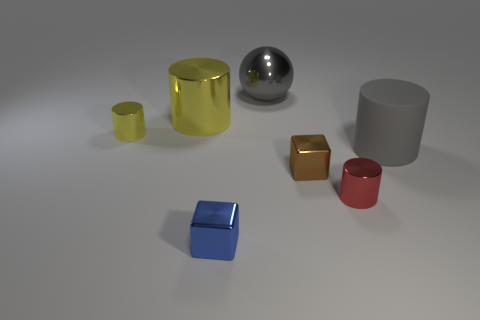Subtract all gray cylinders. How many cylinders are left? 3 Subtract all gray cylinders. How many cylinders are left? 3 Add 3 matte objects. How many objects exist? 10 Subtract all brown cylinders. Subtract all brown balls. How many cylinders are left? 4 Subtract all cylinders. How many objects are left? 3 Subtract all big blue matte spheres. Subtract all big gray matte cylinders. How many objects are left? 6 Add 3 blue objects. How many blue objects are left? 4 Add 3 small brown things. How many small brown things exist? 4 Subtract 0 green balls. How many objects are left? 7 